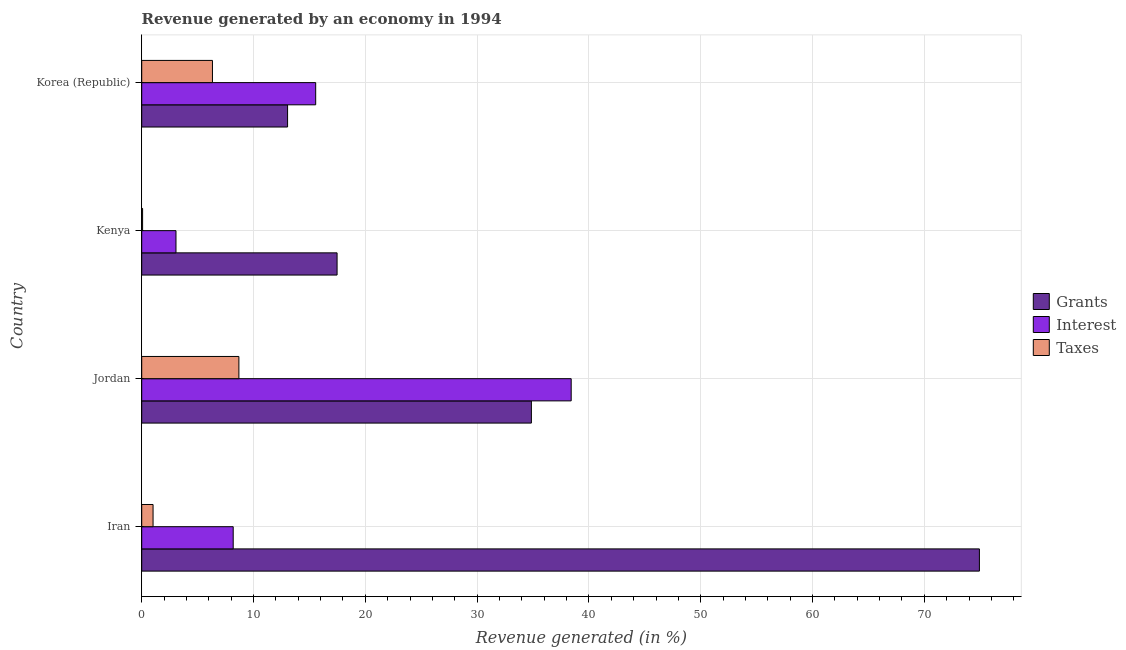How many different coloured bars are there?
Offer a terse response. 3. How many groups of bars are there?
Provide a short and direct response. 4. Are the number of bars on each tick of the Y-axis equal?
Offer a very short reply. Yes. How many bars are there on the 2nd tick from the bottom?
Offer a very short reply. 3. What is the label of the 3rd group of bars from the top?
Offer a terse response. Jordan. In how many cases, is the number of bars for a given country not equal to the number of legend labels?
Provide a short and direct response. 0. What is the percentage of revenue generated by interest in Kenya?
Keep it short and to the point. 3.06. Across all countries, what is the maximum percentage of revenue generated by interest?
Ensure brevity in your answer.  38.41. Across all countries, what is the minimum percentage of revenue generated by grants?
Offer a terse response. 13.05. In which country was the percentage of revenue generated by interest maximum?
Offer a terse response. Jordan. What is the total percentage of revenue generated by interest in the graph?
Your answer should be compact. 65.22. What is the difference between the percentage of revenue generated by interest in Jordan and that in Kenya?
Offer a very short reply. 35.35. What is the difference between the percentage of revenue generated by interest in Kenya and the percentage of revenue generated by grants in Iran?
Your answer should be very brief. -71.86. What is the average percentage of revenue generated by interest per country?
Keep it short and to the point. 16.3. What is the difference between the percentage of revenue generated by interest and percentage of revenue generated by taxes in Jordan?
Make the answer very short. 29.72. What is the ratio of the percentage of revenue generated by interest in Iran to that in Korea (Republic)?
Provide a succinct answer. 0.53. What is the difference between the highest and the second highest percentage of revenue generated by interest?
Give a very brief answer. 22.85. What is the difference between the highest and the lowest percentage of revenue generated by interest?
Give a very brief answer. 35.35. What does the 1st bar from the top in Iran represents?
Provide a short and direct response. Taxes. What does the 1st bar from the bottom in Korea (Republic) represents?
Your answer should be compact. Grants. Is it the case that in every country, the sum of the percentage of revenue generated by grants and percentage of revenue generated by interest is greater than the percentage of revenue generated by taxes?
Your answer should be very brief. Yes. Are all the bars in the graph horizontal?
Make the answer very short. Yes. How many countries are there in the graph?
Provide a short and direct response. 4. What is the difference between two consecutive major ticks on the X-axis?
Ensure brevity in your answer.  10. Does the graph contain any zero values?
Make the answer very short. No. Where does the legend appear in the graph?
Your response must be concise. Center right. How many legend labels are there?
Your answer should be compact. 3. How are the legend labels stacked?
Make the answer very short. Vertical. What is the title of the graph?
Your answer should be compact. Revenue generated by an economy in 1994. Does "Self-employed" appear as one of the legend labels in the graph?
Provide a succinct answer. No. What is the label or title of the X-axis?
Your answer should be very brief. Revenue generated (in %). What is the label or title of the Y-axis?
Your answer should be compact. Country. What is the Revenue generated (in %) of Grants in Iran?
Ensure brevity in your answer.  74.93. What is the Revenue generated (in %) of Interest in Iran?
Your answer should be very brief. 8.18. What is the Revenue generated (in %) of Taxes in Iran?
Your response must be concise. 1.01. What is the Revenue generated (in %) of Grants in Jordan?
Keep it short and to the point. 34.85. What is the Revenue generated (in %) of Interest in Jordan?
Keep it short and to the point. 38.41. What is the Revenue generated (in %) in Taxes in Jordan?
Provide a succinct answer. 8.69. What is the Revenue generated (in %) in Grants in Kenya?
Your answer should be very brief. 17.47. What is the Revenue generated (in %) in Interest in Kenya?
Your answer should be compact. 3.06. What is the Revenue generated (in %) of Taxes in Kenya?
Your answer should be very brief. 0.08. What is the Revenue generated (in %) of Grants in Korea (Republic)?
Your response must be concise. 13.05. What is the Revenue generated (in %) in Interest in Korea (Republic)?
Your answer should be compact. 15.56. What is the Revenue generated (in %) in Taxes in Korea (Republic)?
Your answer should be very brief. 6.33. Across all countries, what is the maximum Revenue generated (in %) of Grants?
Ensure brevity in your answer.  74.93. Across all countries, what is the maximum Revenue generated (in %) of Interest?
Your response must be concise. 38.41. Across all countries, what is the maximum Revenue generated (in %) in Taxes?
Keep it short and to the point. 8.69. Across all countries, what is the minimum Revenue generated (in %) of Grants?
Your answer should be very brief. 13.05. Across all countries, what is the minimum Revenue generated (in %) of Interest?
Keep it short and to the point. 3.06. Across all countries, what is the minimum Revenue generated (in %) of Taxes?
Provide a short and direct response. 0.08. What is the total Revenue generated (in %) of Grants in the graph?
Ensure brevity in your answer.  140.3. What is the total Revenue generated (in %) of Interest in the graph?
Your response must be concise. 65.22. What is the total Revenue generated (in %) in Taxes in the graph?
Give a very brief answer. 16.11. What is the difference between the Revenue generated (in %) of Grants in Iran and that in Jordan?
Offer a very short reply. 40.07. What is the difference between the Revenue generated (in %) in Interest in Iran and that in Jordan?
Ensure brevity in your answer.  -30.23. What is the difference between the Revenue generated (in %) in Taxes in Iran and that in Jordan?
Make the answer very short. -7.68. What is the difference between the Revenue generated (in %) in Grants in Iran and that in Kenya?
Give a very brief answer. 57.45. What is the difference between the Revenue generated (in %) of Interest in Iran and that in Kenya?
Keep it short and to the point. 5.12. What is the difference between the Revenue generated (in %) of Taxes in Iran and that in Kenya?
Your response must be concise. 0.94. What is the difference between the Revenue generated (in %) in Grants in Iran and that in Korea (Republic)?
Give a very brief answer. 61.88. What is the difference between the Revenue generated (in %) in Interest in Iran and that in Korea (Republic)?
Your response must be concise. -7.38. What is the difference between the Revenue generated (in %) of Taxes in Iran and that in Korea (Republic)?
Provide a succinct answer. -5.31. What is the difference between the Revenue generated (in %) of Grants in Jordan and that in Kenya?
Offer a very short reply. 17.38. What is the difference between the Revenue generated (in %) of Interest in Jordan and that in Kenya?
Your response must be concise. 35.35. What is the difference between the Revenue generated (in %) of Taxes in Jordan and that in Kenya?
Offer a terse response. 8.61. What is the difference between the Revenue generated (in %) of Grants in Jordan and that in Korea (Republic)?
Give a very brief answer. 21.81. What is the difference between the Revenue generated (in %) of Interest in Jordan and that in Korea (Republic)?
Offer a very short reply. 22.85. What is the difference between the Revenue generated (in %) of Taxes in Jordan and that in Korea (Republic)?
Provide a succinct answer. 2.37. What is the difference between the Revenue generated (in %) in Grants in Kenya and that in Korea (Republic)?
Your answer should be compact. 4.43. What is the difference between the Revenue generated (in %) in Interest in Kenya and that in Korea (Republic)?
Your answer should be very brief. -12.5. What is the difference between the Revenue generated (in %) of Taxes in Kenya and that in Korea (Republic)?
Your response must be concise. -6.25. What is the difference between the Revenue generated (in %) of Grants in Iran and the Revenue generated (in %) of Interest in Jordan?
Keep it short and to the point. 36.51. What is the difference between the Revenue generated (in %) in Grants in Iran and the Revenue generated (in %) in Taxes in Jordan?
Offer a very short reply. 66.23. What is the difference between the Revenue generated (in %) in Interest in Iran and the Revenue generated (in %) in Taxes in Jordan?
Provide a succinct answer. -0.51. What is the difference between the Revenue generated (in %) of Grants in Iran and the Revenue generated (in %) of Interest in Kenya?
Your answer should be very brief. 71.86. What is the difference between the Revenue generated (in %) in Grants in Iran and the Revenue generated (in %) in Taxes in Kenya?
Make the answer very short. 74.85. What is the difference between the Revenue generated (in %) of Interest in Iran and the Revenue generated (in %) of Taxes in Kenya?
Your answer should be very brief. 8.1. What is the difference between the Revenue generated (in %) in Grants in Iran and the Revenue generated (in %) in Interest in Korea (Republic)?
Your answer should be very brief. 59.37. What is the difference between the Revenue generated (in %) in Grants in Iran and the Revenue generated (in %) in Taxes in Korea (Republic)?
Make the answer very short. 68.6. What is the difference between the Revenue generated (in %) of Interest in Iran and the Revenue generated (in %) of Taxes in Korea (Republic)?
Your answer should be very brief. 1.86. What is the difference between the Revenue generated (in %) in Grants in Jordan and the Revenue generated (in %) in Interest in Kenya?
Your response must be concise. 31.79. What is the difference between the Revenue generated (in %) in Grants in Jordan and the Revenue generated (in %) in Taxes in Kenya?
Make the answer very short. 34.77. What is the difference between the Revenue generated (in %) of Interest in Jordan and the Revenue generated (in %) of Taxes in Kenya?
Your answer should be very brief. 38.33. What is the difference between the Revenue generated (in %) of Grants in Jordan and the Revenue generated (in %) of Interest in Korea (Republic)?
Offer a terse response. 19.29. What is the difference between the Revenue generated (in %) in Grants in Jordan and the Revenue generated (in %) in Taxes in Korea (Republic)?
Offer a very short reply. 28.53. What is the difference between the Revenue generated (in %) in Interest in Jordan and the Revenue generated (in %) in Taxes in Korea (Republic)?
Offer a terse response. 32.09. What is the difference between the Revenue generated (in %) of Grants in Kenya and the Revenue generated (in %) of Interest in Korea (Republic)?
Offer a terse response. 1.91. What is the difference between the Revenue generated (in %) in Grants in Kenya and the Revenue generated (in %) in Taxes in Korea (Republic)?
Offer a terse response. 11.15. What is the difference between the Revenue generated (in %) of Interest in Kenya and the Revenue generated (in %) of Taxes in Korea (Republic)?
Provide a succinct answer. -3.26. What is the average Revenue generated (in %) in Grants per country?
Your answer should be compact. 35.07. What is the average Revenue generated (in %) in Interest per country?
Give a very brief answer. 16.3. What is the average Revenue generated (in %) of Taxes per country?
Offer a terse response. 4.03. What is the difference between the Revenue generated (in %) in Grants and Revenue generated (in %) in Interest in Iran?
Offer a terse response. 66.74. What is the difference between the Revenue generated (in %) in Grants and Revenue generated (in %) in Taxes in Iran?
Your response must be concise. 73.91. What is the difference between the Revenue generated (in %) in Interest and Revenue generated (in %) in Taxes in Iran?
Offer a very short reply. 7.17. What is the difference between the Revenue generated (in %) of Grants and Revenue generated (in %) of Interest in Jordan?
Provide a succinct answer. -3.56. What is the difference between the Revenue generated (in %) in Grants and Revenue generated (in %) in Taxes in Jordan?
Offer a terse response. 26.16. What is the difference between the Revenue generated (in %) in Interest and Revenue generated (in %) in Taxes in Jordan?
Keep it short and to the point. 29.72. What is the difference between the Revenue generated (in %) in Grants and Revenue generated (in %) in Interest in Kenya?
Offer a very short reply. 14.41. What is the difference between the Revenue generated (in %) of Grants and Revenue generated (in %) of Taxes in Kenya?
Offer a terse response. 17.39. What is the difference between the Revenue generated (in %) of Interest and Revenue generated (in %) of Taxes in Kenya?
Give a very brief answer. 2.99. What is the difference between the Revenue generated (in %) in Grants and Revenue generated (in %) in Interest in Korea (Republic)?
Offer a terse response. -2.51. What is the difference between the Revenue generated (in %) of Grants and Revenue generated (in %) of Taxes in Korea (Republic)?
Provide a succinct answer. 6.72. What is the difference between the Revenue generated (in %) in Interest and Revenue generated (in %) in Taxes in Korea (Republic)?
Your answer should be very brief. 9.23. What is the ratio of the Revenue generated (in %) of Grants in Iran to that in Jordan?
Provide a short and direct response. 2.15. What is the ratio of the Revenue generated (in %) of Interest in Iran to that in Jordan?
Your answer should be compact. 0.21. What is the ratio of the Revenue generated (in %) in Taxes in Iran to that in Jordan?
Provide a short and direct response. 0.12. What is the ratio of the Revenue generated (in %) of Grants in Iran to that in Kenya?
Your answer should be very brief. 4.29. What is the ratio of the Revenue generated (in %) of Interest in Iran to that in Kenya?
Offer a terse response. 2.67. What is the ratio of the Revenue generated (in %) of Taxes in Iran to that in Kenya?
Offer a very short reply. 12.9. What is the ratio of the Revenue generated (in %) in Grants in Iran to that in Korea (Republic)?
Offer a very short reply. 5.74. What is the ratio of the Revenue generated (in %) of Interest in Iran to that in Korea (Republic)?
Ensure brevity in your answer.  0.53. What is the ratio of the Revenue generated (in %) of Taxes in Iran to that in Korea (Republic)?
Provide a succinct answer. 0.16. What is the ratio of the Revenue generated (in %) of Grants in Jordan to that in Kenya?
Provide a succinct answer. 1.99. What is the ratio of the Revenue generated (in %) in Interest in Jordan to that in Kenya?
Provide a short and direct response. 12.54. What is the ratio of the Revenue generated (in %) of Taxes in Jordan to that in Kenya?
Give a very brief answer. 110.6. What is the ratio of the Revenue generated (in %) in Grants in Jordan to that in Korea (Republic)?
Your answer should be compact. 2.67. What is the ratio of the Revenue generated (in %) in Interest in Jordan to that in Korea (Republic)?
Offer a terse response. 2.47. What is the ratio of the Revenue generated (in %) of Taxes in Jordan to that in Korea (Republic)?
Offer a terse response. 1.37. What is the ratio of the Revenue generated (in %) in Grants in Kenya to that in Korea (Republic)?
Offer a very short reply. 1.34. What is the ratio of the Revenue generated (in %) of Interest in Kenya to that in Korea (Republic)?
Provide a short and direct response. 0.2. What is the ratio of the Revenue generated (in %) of Taxes in Kenya to that in Korea (Republic)?
Make the answer very short. 0.01. What is the difference between the highest and the second highest Revenue generated (in %) in Grants?
Keep it short and to the point. 40.07. What is the difference between the highest and the second highest Revenue generated (in %) of Interest?
Make the answer very short. 22.85. What is the difference between the highest and the second highest Revenue generated (in %) of Taxes?
Your response must be concise. 2.37. What is the difference between the highest and the lowest Revenue generated (in %) of Grants?
Keep it short and to the point. 61.88. What is the difference between the highest and the lowest Revenue generated (in %) in Interest?
Your answer should be compact. 35.35. What is the difference between the highest and the lowest Revenue generated (in %) in Taxes?
Keep it short and to the point. 8.61. 